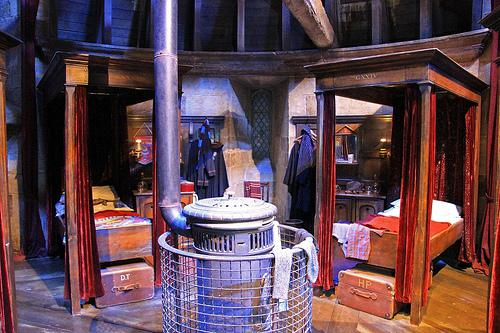Question: what movie is this set from?
Choices:
A. Star Wars.
B. Harry potter.
C. Indiana Jones.
D. James Bond.
Answer with the letter. Answer: B Question: who has the initials HP?
Choices:
A. Henry Plummer.
B. Harry Potter.
C. Hank Pluskett.
D. Harry Pinter.
Answer with the letter. Answer: B Question: what color are the blankets on the bed?
Choices:
A. Orange.
B. Yellow.
C. Black.
D. Red.
Answer with the letter. Answer: D Question: where is this room located?
Choices:
A. White House.
B. School.
C. Museum.
D. Hogwarts.
Answer with the letter. Answer: D Question: how many beds do you see in the photo?
Choices:
A. 1.
B. 2.
C. 0.
D. 3.
Answer with the letter. Answer: B 